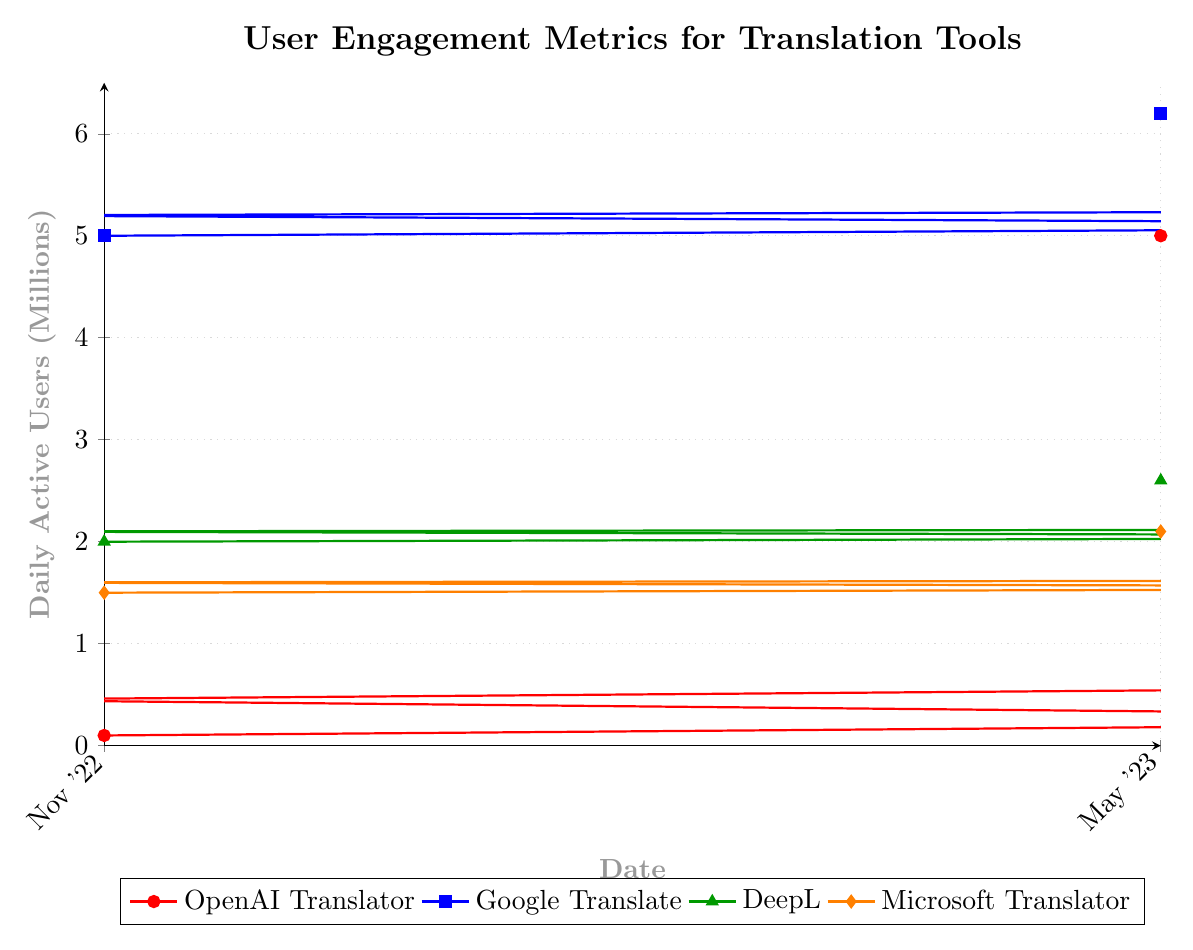How many users does OpenAI Translator have on March 1, 2023? Locate the "OpenAI Translator" line (red) on the March 1, 2023 data point. The corresponding value is 2.5 million.
Answer: 2.5 million By how many users did OpenAI Translator's daily active users increase from January 1, 2023, to April 1, 2023? Find the users for OpenAI Translator on January 1, 2023 (0.75 million) and April 1, 2023 (3.5 million). Subtract the former from the latter: 3.5 - 0.75 = 2.75 million.
Answer: 2.75 million Which month saw the highest increase in daily active users for OpenAI Translator compared to the previous month? Observe the monthly increments on the "OpenAI Translator" line (red). Notice that from January 15, 2023 (1 million) to February 1, 2023 (1.5 million), there is the highest increase of 0.5 million.
Answer: February 2023 What can be inferred about the trend of daily active users for Google Translate over the given period? View the "Google Translate" line (blue). It shows a consistent upward trend without any decline, ranging from 5 million in November 2022 to 6.2 million in May 2023.
Answer: Consistent growth On May 1, 2023, which translation tool had the least number of daily active users? Compare data points for all tools on May 1, 2023. OpenAI Translator had 4.5 million, Google Translate had 6.1 million, DeepL had 2.55 million, and Microsoft Translator had 2.05 million. Microsoft Translator had the least with 2.05 million.
Answer: Microsoft Translator Compare the daily active users for OpenAI Translator and DeepL on February 15, 2023. Identify the counts for both tools on February 15, 2023. OpenAI Translator had 2 million users, and DeepL had 2.3 million users.
Answer: DeepL had more users than OpenAI Translator What is the average number of daily active users for Microsoft Translator from November 2022 to May 2023? List the counts for Microsoft Translator, which are 1.5, 1.55, 1.6, 1.65, 1.7, 1.75, 1.8, 1.85, 1.9, 1.95, 2.0, 2.05, and 2.1 million. Sum these values and divide by 13: (1.5+1.55+1.6+1.65+1.7+1.75+1.8+1.85+1.9+1.95+2.0+2.05+2.1)/13 = 1.819 million.
Answer: 1.819 million 